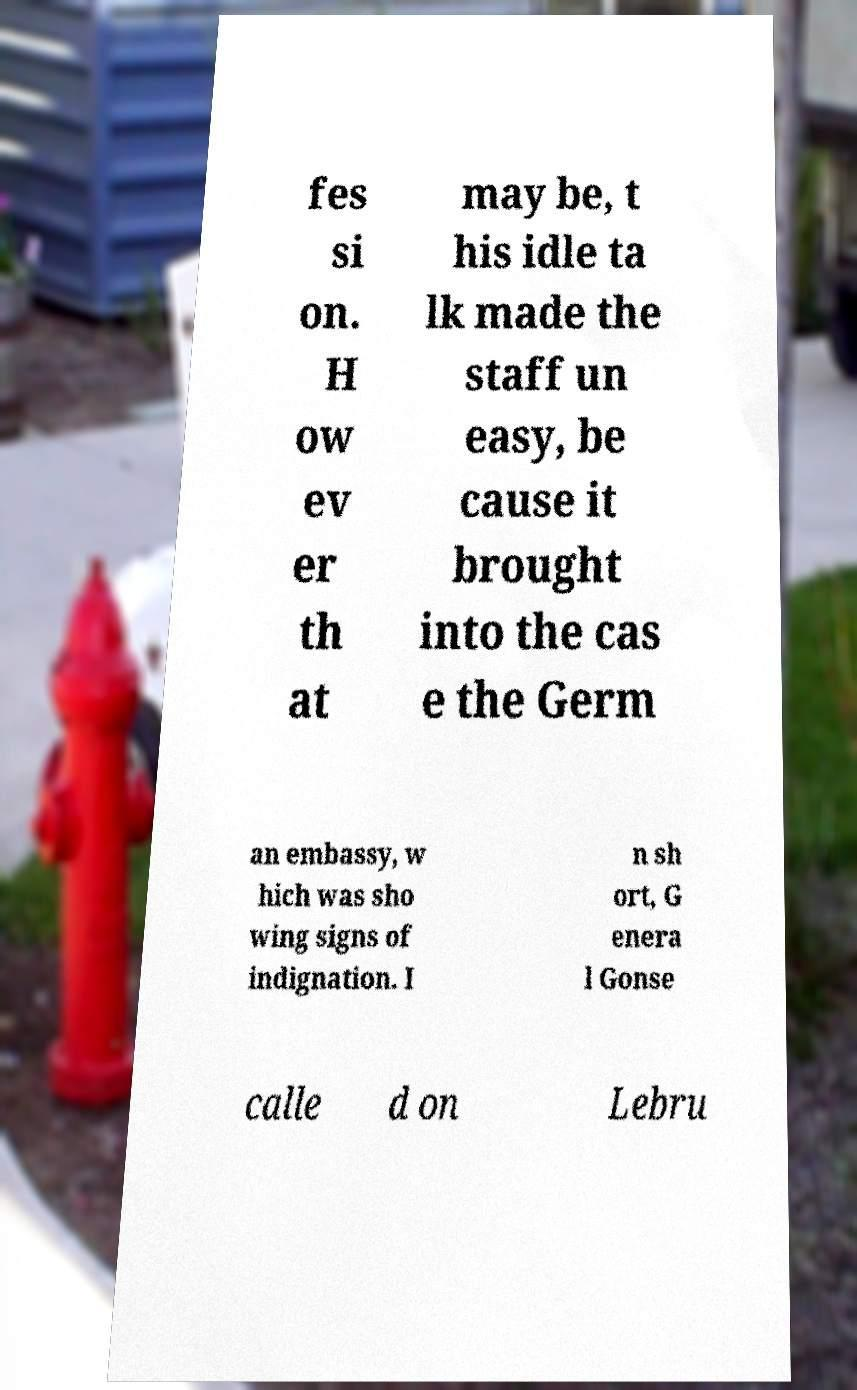What messages or text are displayed in this image? I need them in a readable, typed format. fes si on. H ow ev er th at may be, t his idle ta lk made the staff un easy, be cause it brought into the cas e the Germ an embassy, w hich was sho wing signs of indignation. I n sh ort, G enera l Gonse calle d on Lebru 